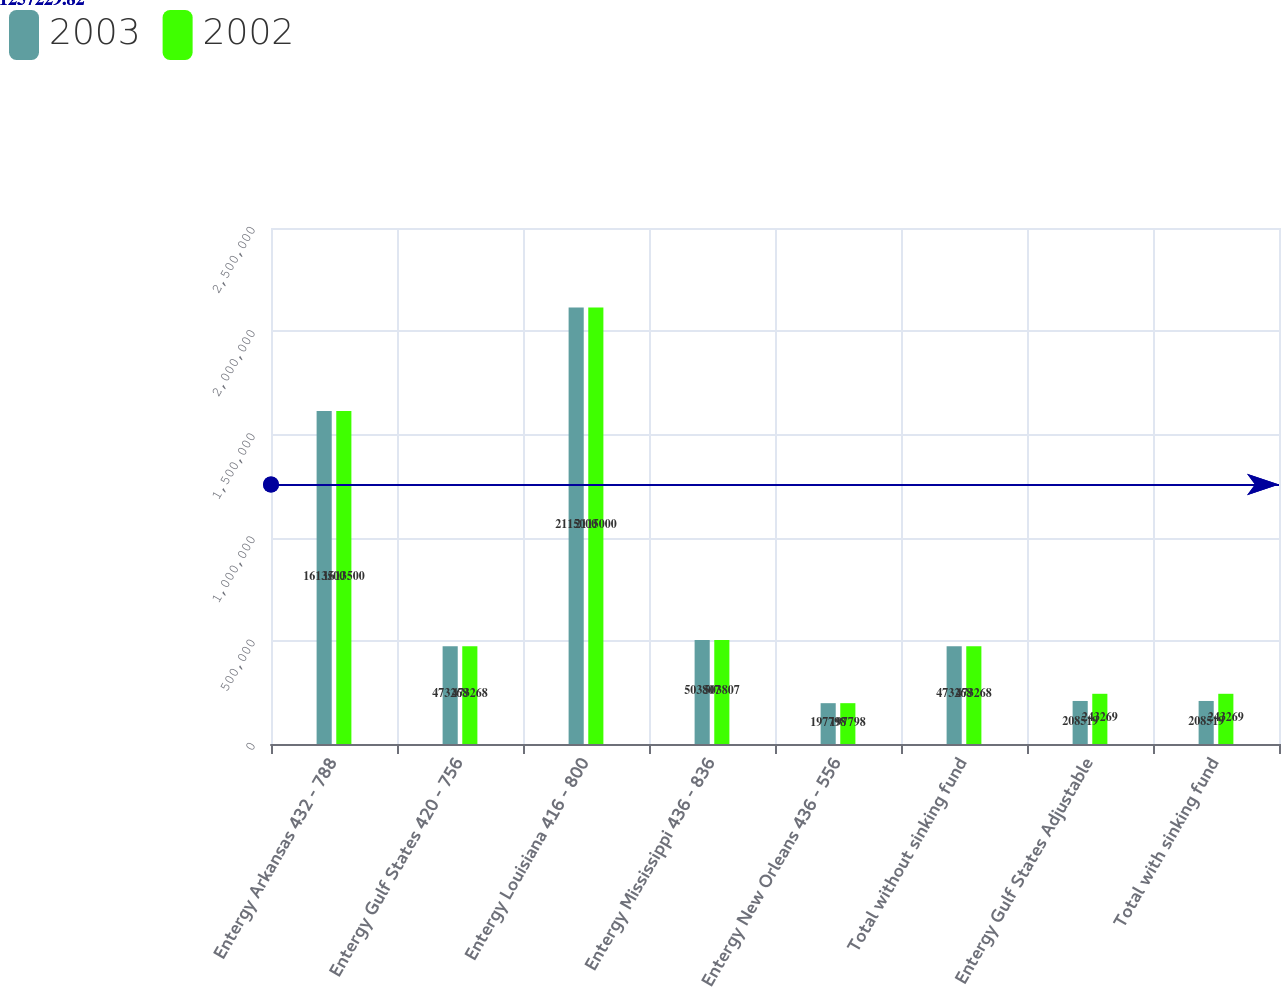Convert chart to OTSL. <chart><loc_0><loc_0><loc_500><loc_500><stacked_bar_chart><ecel><fcel>Entergy Arkansas 432 - 788<fcel>Entergy Gulf States 420 - 756<fcel>Entergy Louisiana 416 - 800<fcel>Entergy Mississippi 436 - 836<fcel>Entergy New Orleans 436 - 556<fcel>Total without sinking fund<fcel>Entergy Gulf States Adjustable<fcel>Total with sinking fund<nl><fcel>2003<fcel>1.6135e+06<fcel>473268<fcel>2.115e+06<fcel>503807<fcel>197798<fcel>473268<fcel>208519<fcel>208519<nl><fcel>2002<fcel>1.6135e+06<fcel>473268<fcel>2.115e+06<fcel>503807<fcel>197798<fcel>473268<fcel>243269<fcel>243269<nl></chart> 